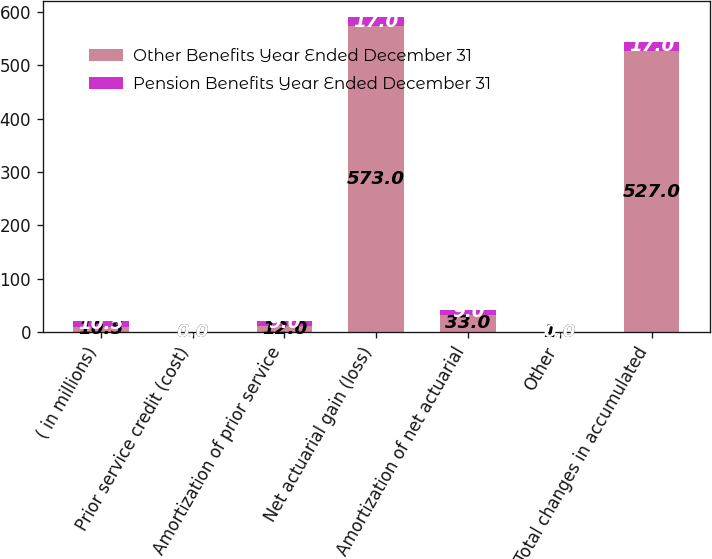Convert chart. <chart><loc_0><loc_0><loc_500><loc_500><stacked_bar_chart><ecel><fcel>( in millions)<fcel>Prior service credit (cost)<fcel>Amortization of prior service<fcel>Net actuarial gain (loss)<fcel>Amortization of net actuarial<fcel>Other<fcel>Total changes in accumulated<nl><fcel>Other Benefits Year Ended December 31<fcel>10.5<fcel>0<fcel>12<fcel>573<fcel>33<fcel>1<fcel>527<nl><fcel>Pension Benefits Year Ended December 31<fcel>10.5<fcel>0<fcel>9<fcel>17<fcel>9<fcel>0<fcel>17<nl></chart> 